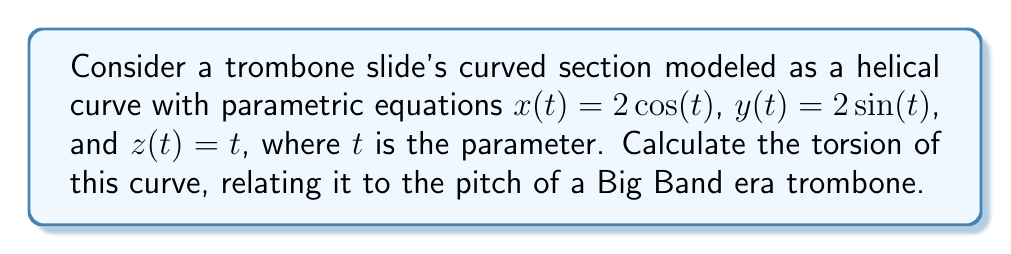Provide a solution to this math problem. To analyze the torsion of the trombone slide's curved section, we'll follow these steps:

1) The torsion of a curve is given by the formula:

   $$\tau = \frac{(\mathbf{r'} \times \mathbf{r''}) \cdot \mathbf{r'''}}{|\mathbf{r'} \times \mathbf{r''}|^2}$$

   where $\mathbf{r}(t) = (x(t), y(t), z(t))$ is the position vector.

2) First, let's calculate $\mathbf{r'}$, $\mathbf{r''}$, and $\mathbf{r'''}$:

   $\mathbf{r'} = (-2\sin(t), 2\cos(t), 1)$
   $\mathbf{r''} = (-2\cos(t), -2\sin(t), 0)$
   $\mathbf{r'''} = (2\sin(t), -2\cos(t), 0)$

3) Now, let's calculate $\mathbf{r'} \times \mathbf{r''}$:

   $\mathbf{r'} \times \mathbf{r''} = (2, 2, 4)$

4) Next, $(\mathbf{r'} \times \mathbf{r''}) \cdot \mathbf{r'''}$:

   $(\mathbf{r'} \times \mathbf{r''}) \cdot \mathbf{r'''} = 2(2\sin(t)) + 2(-2\cos(t)) + 4(0) = 4\sin(t) - 4\cos(t) = 4$

5) Finally, $|\mathbf{r'} \times \mathbf{r''}|^2$:

   $|\mathbf{r'} \times \mathbf{r''}|^2 = 2^2 + 2^2 + 4^2 = 24$

6) Substituting into the torsion formula:

   $$\tau = \frac{4}{24} = \frac{1}{6}$$

This constant torsion indicates a uniform twisting of the curve, which in the context of a trombone slide, contributes to the instrument's consistent pitch across its range, a characteristic highly valued in Big Band era trombones for their ability to produce clear, precise notes in fast-paced swing arrangements.
Answer: $\frac{1}{6}$ 